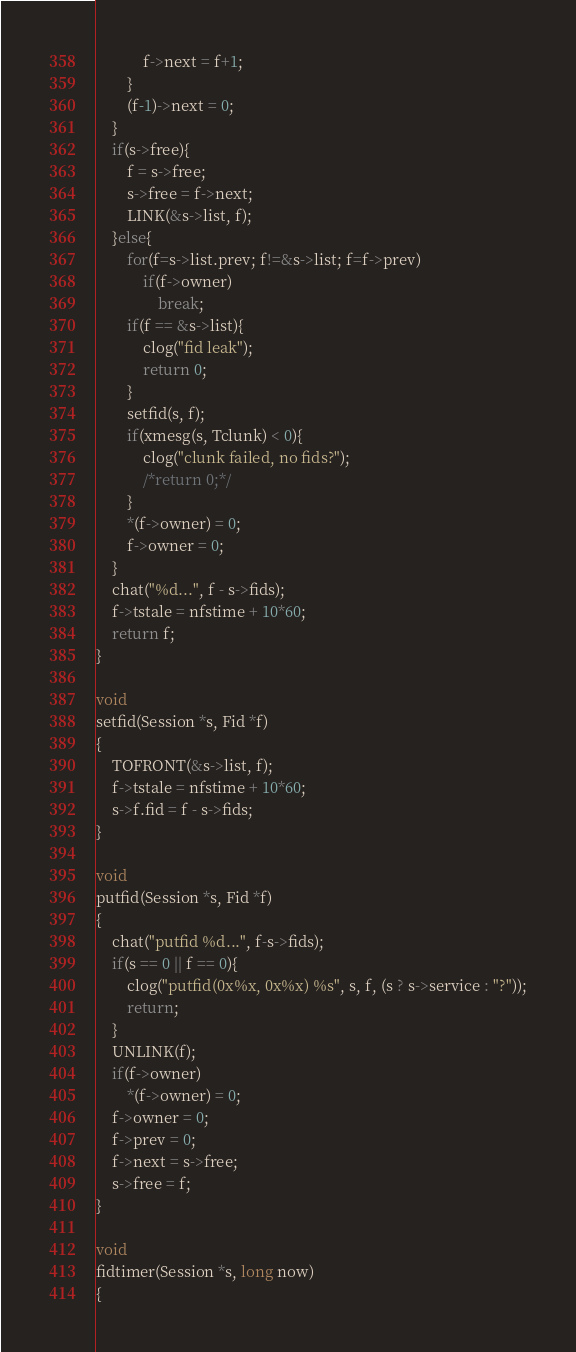<code> <loc_0><loc_0><loc_500><loc_500><_C_>			f->next = f+1;
		}
		(f-1)->next = 0;
	}
	if(s->free){
		f = s->free;
		s->free = f->next;
		LINK(&s->list, f);
	}else{
		for(f=s->list.prev; f!=&s->list; f=f->prev)
			if(f->owner)
				break;
		if(f == &s->list){
			clog("fid leak");
			return 0;
		}
		setfid(s, f);
		if(xmesg(s, Tclunk) < 0){
			clog("clunk failed, no fids?");
			/*return 0;*/
		}
		*(f->owner) = 0;
		f->owner = 0;
	}
	chat("%d...", f - s->fids);
	f->tstale = nfstime + 10*60;
	return f;
}

void
setfid(Session *s, Fid *f)
{
	TOFRONT(&s->list, f);
	f->tstale = nfstime + 10*60;
	s->f.fid = f - s->fids;
}

void
putfid(Session *s, Fid *f)
{
	chat("putfid %d...", f-s->fids);
	if(s == 0 || f == 0){
		clog("putfid(0x%x, 0x%x) %s", s, f, (s ? s->service : "?"));
		return;
	}
	UNLINK(f);
	if(f->owner)
		*(f->owner) = 0;
	f->owner = 0;
	f->prev = 0;
	f->next = s->free;
	s->free = f;
}

void
fidtimer(Session *s, long now)
{</code> 